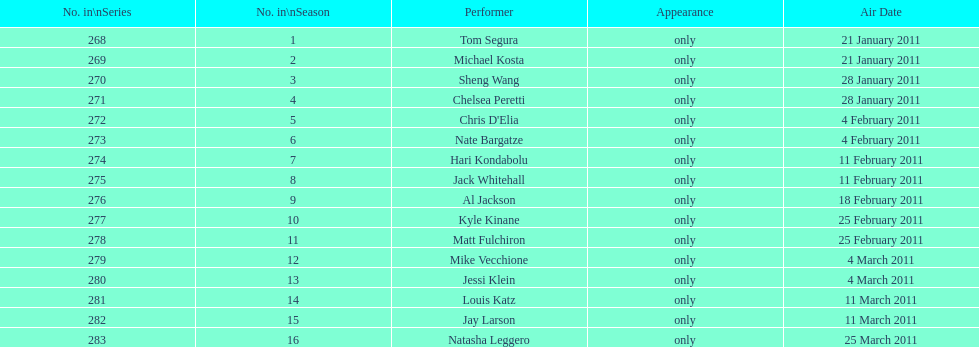What was hari's last name? Kondabolu. 